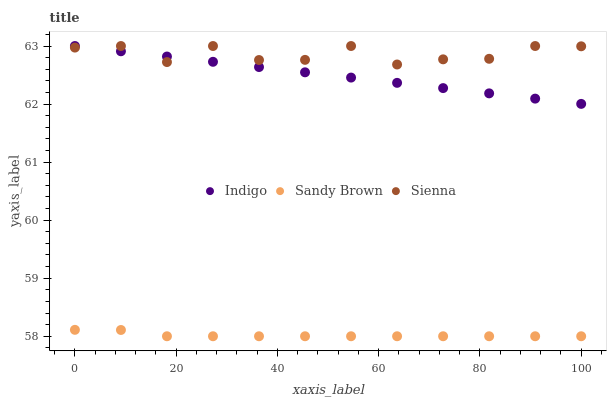Does Sandy Brown have the minimum area under the curve?
Answer yes or no. Yes. Does Sienna have the maximum area under the curve?
Answer yes or no. Yes. Does Indigo have the minimum area under the curve?
Answer yes or no. No. Does Indigo have the maximum area under the curve?
Answer yes or no. No. Is Indigo the smoothest?
Answer yes or no. Yes. Is Sienna the roughest?
Answer yes or no. Yes. Is Sandy Brown the smoothest?
Answer yes or no. No. Is Sandy Brown the roughest?
Answer yes or no. No. Does Sandy Brown have the lowest value?
Answer yes or no. Yes. Does Indigo have the lowest value?
Answer yes or no. No. Does Indigo have the highest value?
Answer yes or no. Yes. Does Sandy Brown have the highest value?
Answer yes or no. No. Is Sandy Brown less than Indigo?
Answer yes or no. Yes. Is Indigo greater than Sandy Brown?
Answer yes or no. Yes. Does Sienna intersect Indigo?
Answer yes or no. Yes. Is Sienna less than Indigo?
Answer yes or no. No. Is Sienna greater than Indigo?
Answer yes or no. No. Does Sandy Brown intersect Indigo?
Answer yes or no. No. 